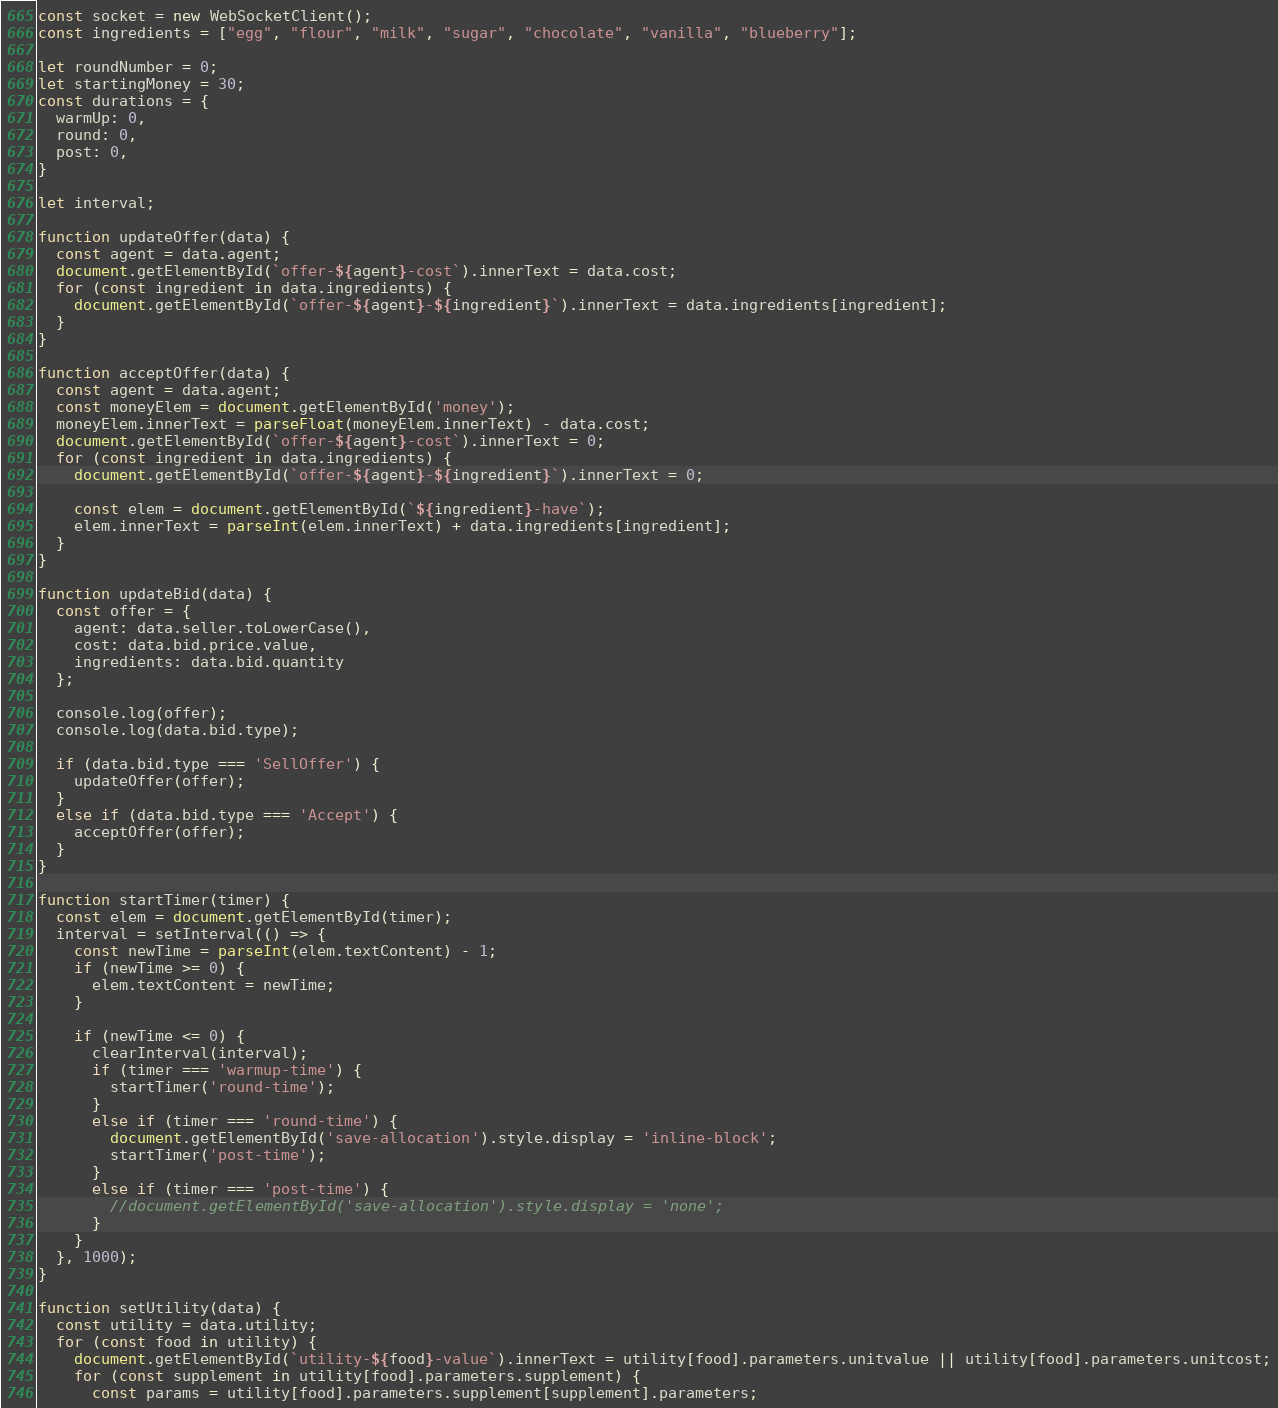Convert code to text. <code><loc_0><loc_0><loc_500><loc_500><_JavaScript_>const socket = new WebSocketClient();
const ingredients = ["egg", "flour", "milk", "sugar", "chocolate", "vanilla", "blueberry"];

let roundNumber = 0;
let startingMoney = 30;
const durations = {
  warmUp: 0,
  round: 0,
  post: 0,
}

let interval;

function updateOffer(data) {
  const agent = data.agent;
  document.getElementById(`offer-${agent}-cost`).innerText = data.cost;
  for (const ingredient in data.ingredients) {
    document.getElementById(`offer-${agent}-${ingredient}`).innerText = data.ingredients[ingredient];
  }
}

function acceptOffer(data) {
  const agent = data.agent;
  const moneyElem = document.getElementById('money');
  moneyElem.innerText = parseFloat(moneyElem.innerText) - data.cost;
  document.getElementById(`offer-${agent}-cost`).innerText = 0;
  for (const ingredient in data.ingredients) {
    document.getElementById(`offer-${agent}-${ingredient}`).innerText = 0;

    const elem = document.getElementById(`${ingredient}-have`);
    elem.innerText = parseInt(elem.innerText) + data.ingredients[ingredient];
  }
}

function updateBid(data) {
  const offer = {
    agent: data.seller.toLowerCase(),
    cost: data.bid.price.value,
    ingredients: data.bid.quantity
  };

  console.log(offer);
  console.log(data.bid.type);

  if (data.bid.type === 'SellOffer') {
    updateOffer(offer);
  }
  else if (data.bid.type === 'Accept') {
    acceptOffer(offer);
  }
}

function startTimer(timer) {
  const elem = document.getElementById(timer);
  interval = setInterval(() => {
    const newTime = parseInt(elem.textContent) - 1;
    if (newTime >= 0) {
      elem.textContent = newTime;
    }

    if (newTime <= 0) {
      clearInterval(interval);
      if (timer === 'warmup-time') {
        startTimer('round-time');
      }
      else if (timer === 'round-time') {
        document.getElementById('save-allocation').style.display = 'inline-block';
        startTimer('post-time');
      }
      else if (timer === 'post-time') {
        //document.getElementById('save-allocation').style.display = 'none';
      }
    }
  }, 1000);
}

function setUtility(data) {
  const utility = data.utility;
  for (const food in utility) {
    document.getElementById(`utility-${food}-value`).innerText = utility[food].parameters.unitvalue || utility[food].parameters.unitcost;
    for (const supplement in utility[food].parameters.supplement) {
      const params = utility[food].parameters.supplement[supplement].parameters;</code> 